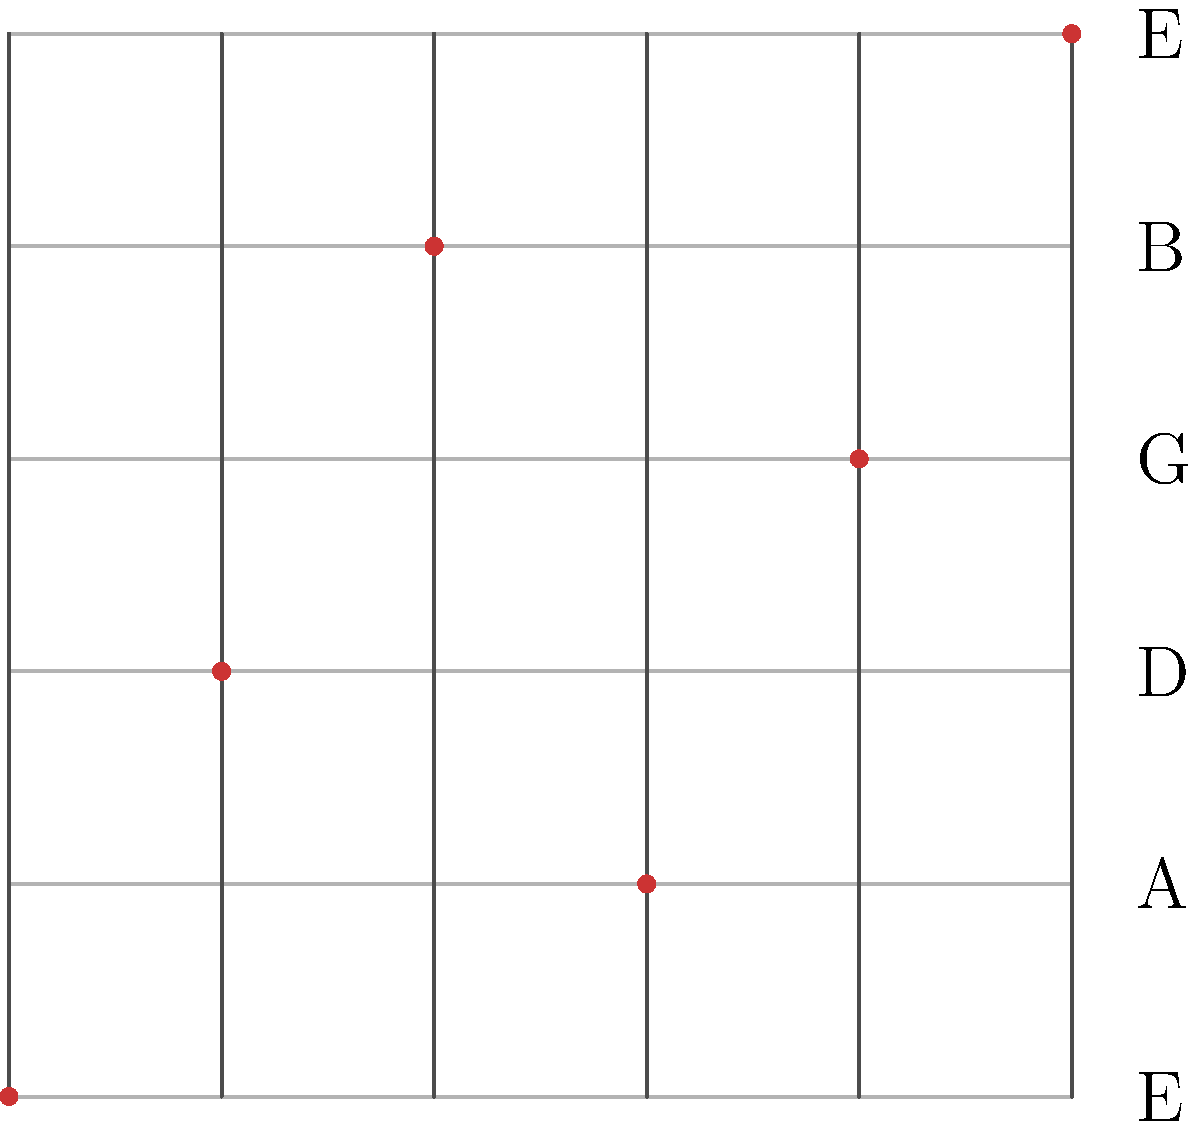As a devoted fan of Tom Brock's intricate guitar work, you've noticed a recurring pattern in his fretboard movements. The diagram shows a representation of a guitar fretboard with a specific note pattern. Which symmetry operation would transform this pattern into itself? Let's analyze the symmetry of the given fretboard pattern step-by-step:

1. Observe the pattern: The notes form a diagonal line from the bottom-left to the top-right of the fretboard.

2. Consider possible symmetry operations:
   a) Rotation: Rotating the pattern would not preserve its structure.
   b) Reflection: There is no line of reflection that would keep the pattern unchanged.
   c) Translation: Moving the pattern horizontally or vertically would change its position on the fretboard.
   d) Glide reflection: This combines a reflection and a translation.

3. Analyze the glide reflection:
   - If we reflect the pattern across a horizontal line in the middle of the fretboard (between the 3rd and 4th strings), the diagonal line would be flipped.
   - Then, if we translate this flipped pattern up by 3 frets (half the fretboard height), it would align perfectly with the original pattern.

4. Mathematically, this glide reflection can be represented as:
   $$(x, y) \rightarrow (x, -y + 5)$$
   where $x$ is the fret number (0-5) and $y$ is the string number (0-5).

5. Verify: Applying this transformation to each note in the pattern will indeed map it back onto itself.

Therefore, the symmetry operation that transforms this pattern into itself is a glide reflection.
Answer: Glide reflection 